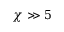<formula> <loc_0><loc_0><loc_500><loc_500>\chi \gg 5</formula> 